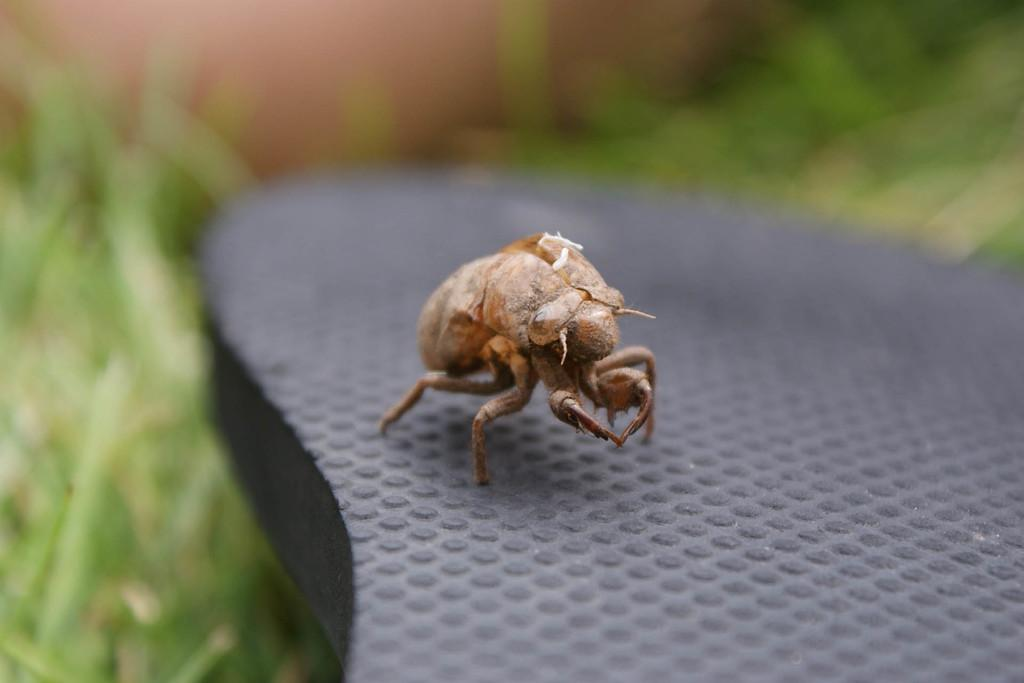What type of creature is present in the image? There is an insect in the image. What is the color of the surface where the insect is located? The insect is on a black surface. Can you describe the background of the image? The background of the image is blurred. What type of toothbrush is the insect using in the image? There is no toothbrush present in the image, and the insect is not using any tool or object. 